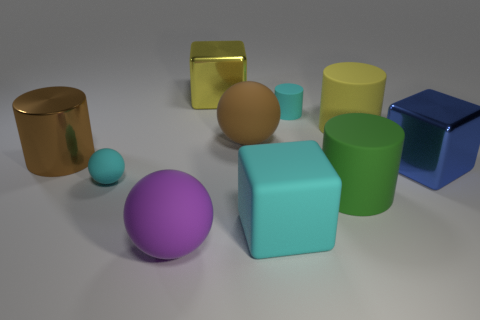Subtract 1 cylinders. How many cylinders are left? 3 Subtract all balls. How many objects are left? 7 Add 6 big blue objects. How many big blue objects exist? 7 Subtract 0 brown cubes. How many objects are left? 10 Subtract all large yellow metal objects. Subtract all large brown matte objects. How many objects are left? 8 Add 9 yellow shiny things. How many yellow shiny things are left? 10 